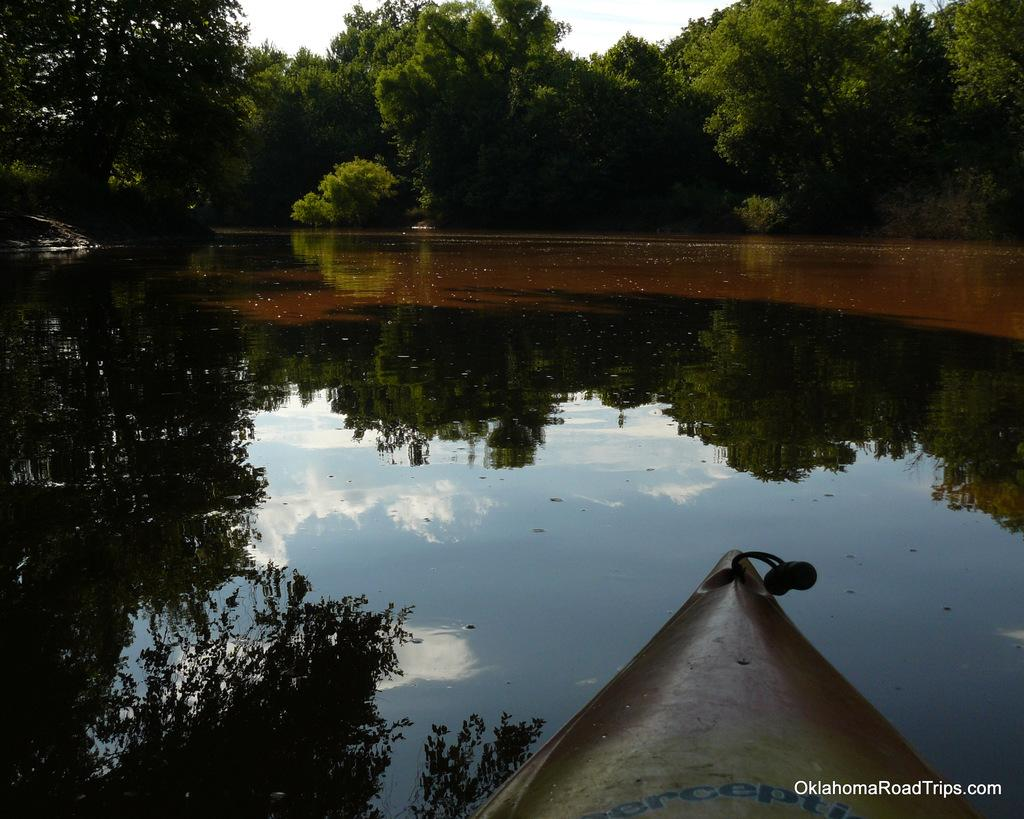What type of body of water is depicted in the image? The image consists of a pond or a lake. What is the primary element in the middle of the image? There is water in the middle of the image. What type of vehicle is present at the bottom of the image? There is a boat at the bottom of the image. What can be seen in the background of the image? There are many trees in the background of the image. What is visible at the top of the image? The sky is visible at the top of the image. What type of straw is being used by the donkey in the image? There is no donkey or straw present in the image. How does the neck of the donkey appear in the image? There is no donkey or neck present in the image. 